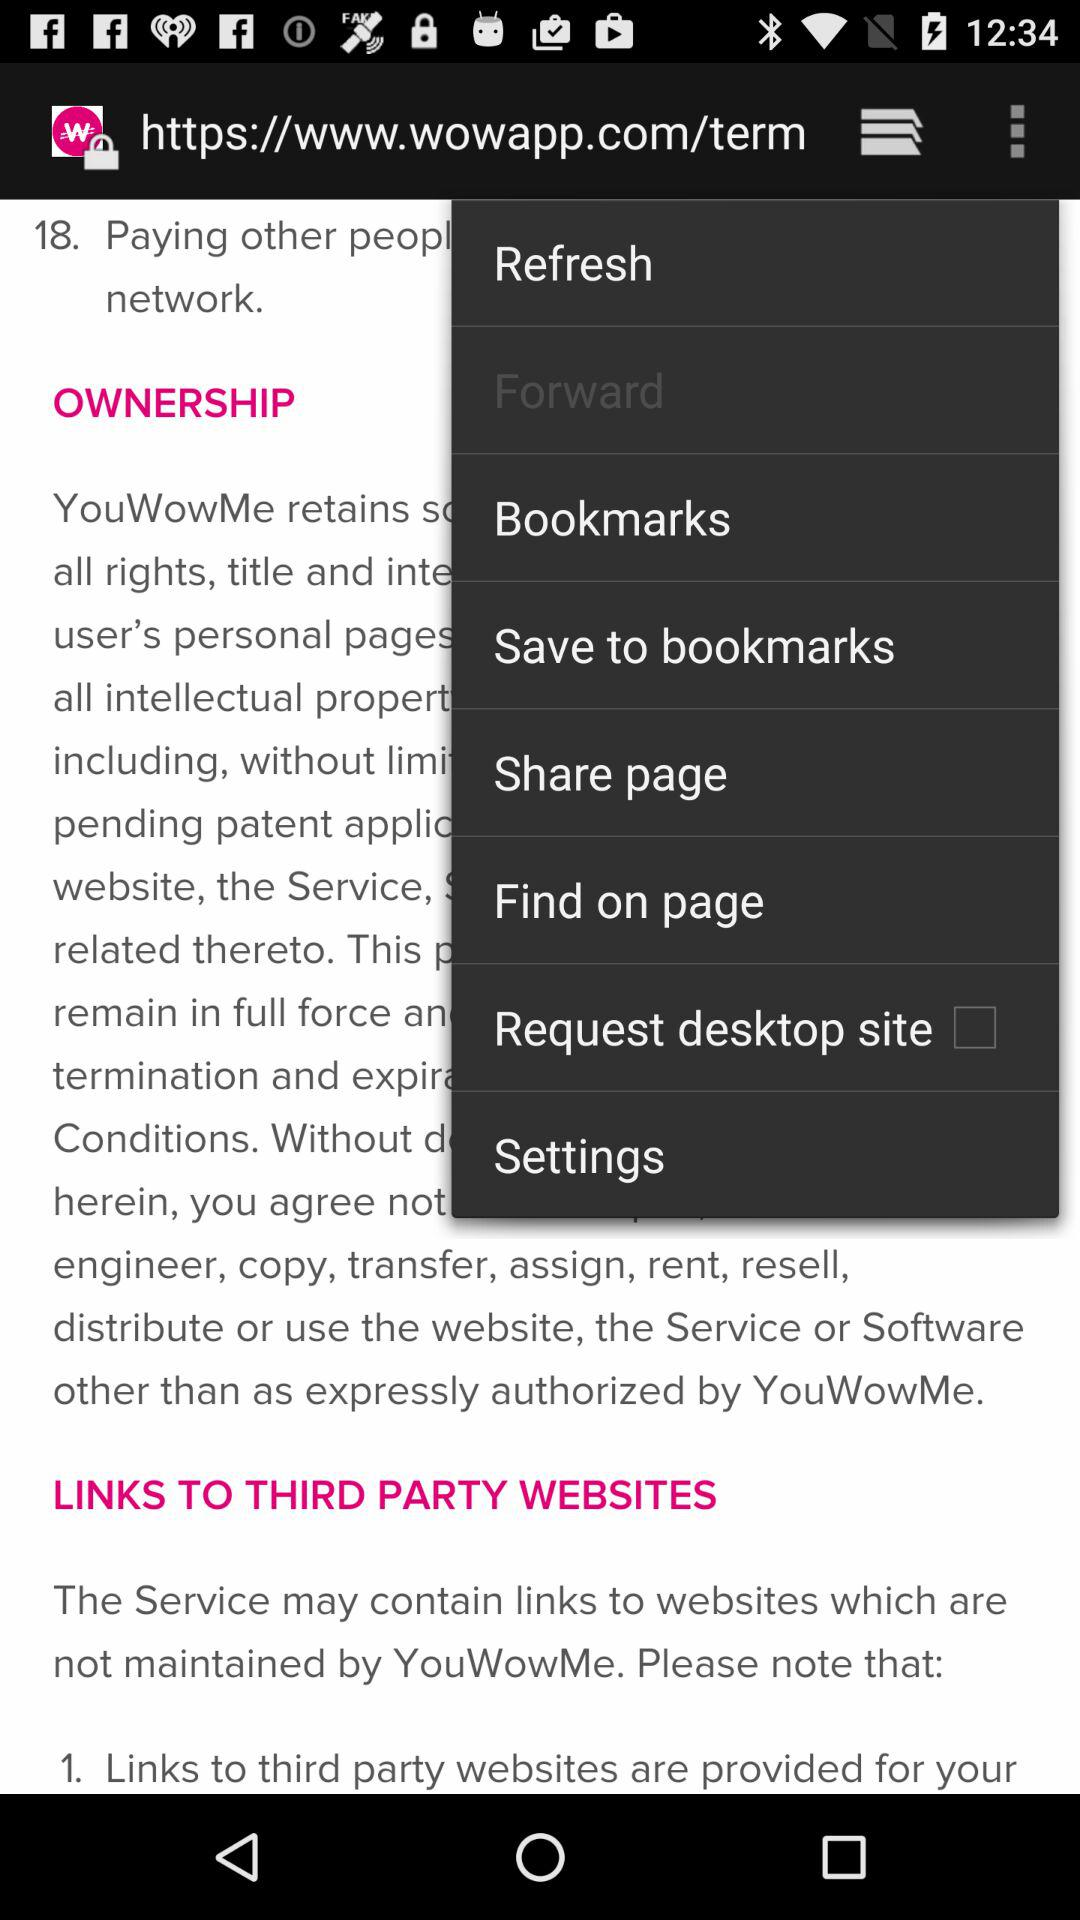What is the status of the "Request desktop site"? The status is off. 